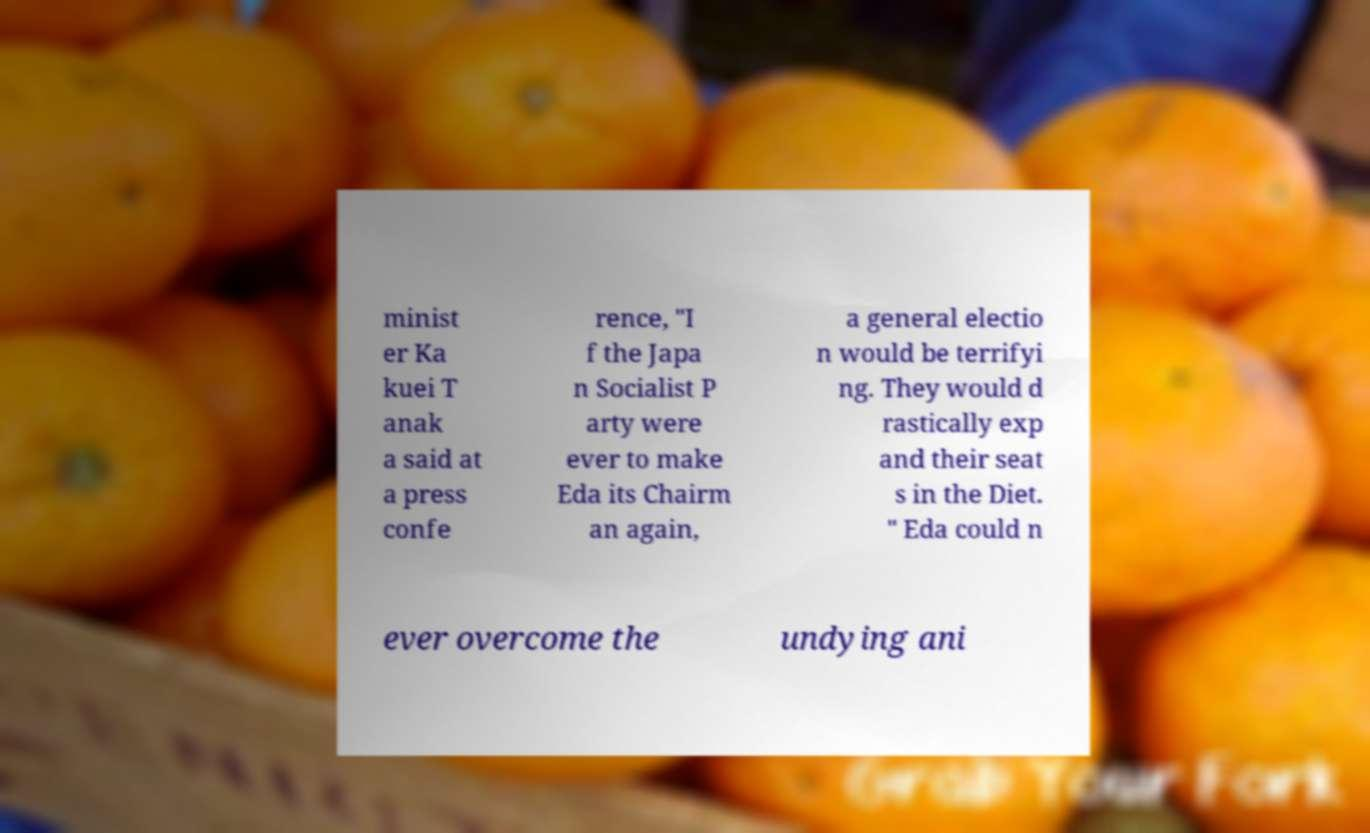Please read and relay the text visible in this image. What does it say? minist er Ka kuei T anak a said at a press confe rence, "I f the Japa n Socialist P arty were ever to make Eda its Chairm an again, a general electio n would be terrifyi ng. They would d rastically exp and their seat s in the Diet. " Eda could n ever overcome the undying ani 